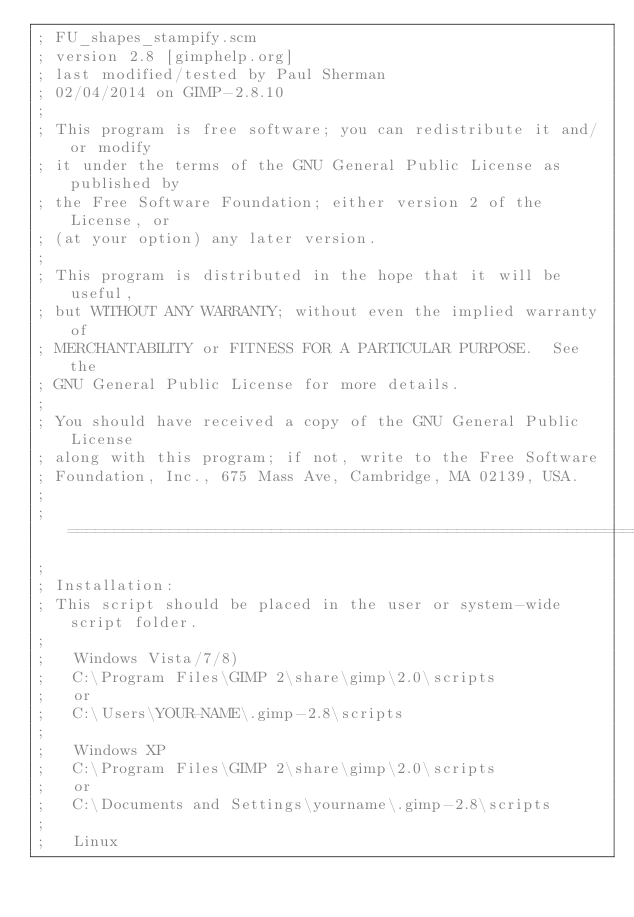<code> <loc_0><loc_0><loc_500><loc_500><_Scheme_>; FU_shapes_stampify.scm
; version 2.8 [gimphelp.org]
; last modified/tested by Paul Sherman
; 02/04/2014 on GIMP-2.8.10
;
; This program is free software; you can redistribute it and/or modify
; it under the terms of the GNU General Public License as published by
; the Free Software Foundation; either version 2 of the License, or
; (at your option) any later version.
; 
; This program is distributed in the hope that it will be useful,
; but WITHOUT ANY WARRANTY; without even the implied warranty of
; MERCHANTABILITY or FITNESS FOR A PARTICULAR PURPOSE.  See the
; GNU General Public License for more details.
; 
; You should have received a copy of the GNU General Public License
; along with this program; if not, write to the Free Software
; Foundation, Inc., 675 Mass Ave, Cambridge, MA 02139, USA.
;
;==============================================================
;
; Installation:
; This script should be placed in the user or system-wide script folder.
;
;	Windows Vista/7/8)
;	C:\Program Files\GIMP 2\share\gimp\2.0\scripts
;	or
;	C:\Users\YOUR-NAME\.gimp-2.8\scripts
;	
;	Windows XP
;	C:\Program Files\GIMP 2\share\gimp\2.0\scripts
;	or
;	C:\Documents and Settings\yourname\.gimp-2.8\scripts   
;    
;	Linux</code> 